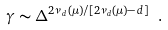Convert formula to latex. <formula><loc_0><loc_0><loc_500><loc_500>\gamma \sim \Delta ^ { 2 \nu _ { d } ( \mu ) / [ 2 \nu _ { d } ( \mu ) - d ] } \ .</formula> 